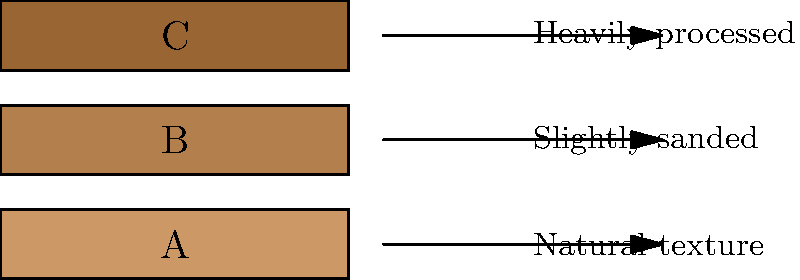As a traditional saddle maker, you know the importance of selecting the right leather for your craftsmanship. The image shows three types of leather grain patterns labeled A, B, and C. Which of these represents full-grain leather, known for its durability and natural characteristics? To identify full-grain leather, we need to consider the characteristics of each type shown in the image:

1. Pattern A: This shows a natural texture with visible pores and imperfections, typical of full-grain leather. Full-grain leather is the highest quality and most durable, as it retains the entire grain layer of the hide.

2. Pattern B: This appears slightly smoother than A, indicating some surface processing. This is likely top-grain leather, which has had the very top layer of the hide sanded to remove imperfections.

3. Pattern C: This shows a very uniform, heavily processed surface. This is characteristic of corrected-grain leather, which has been sanded and embossed to create a consistent appearance.

For a traditional saddle maker who values natural characteristics and durability, full-grain leather (Pattern A) would be the preferred choice. It ages beautifully, develops a patina over time, and maintains the inherent strength of the hide.
Answer: A 